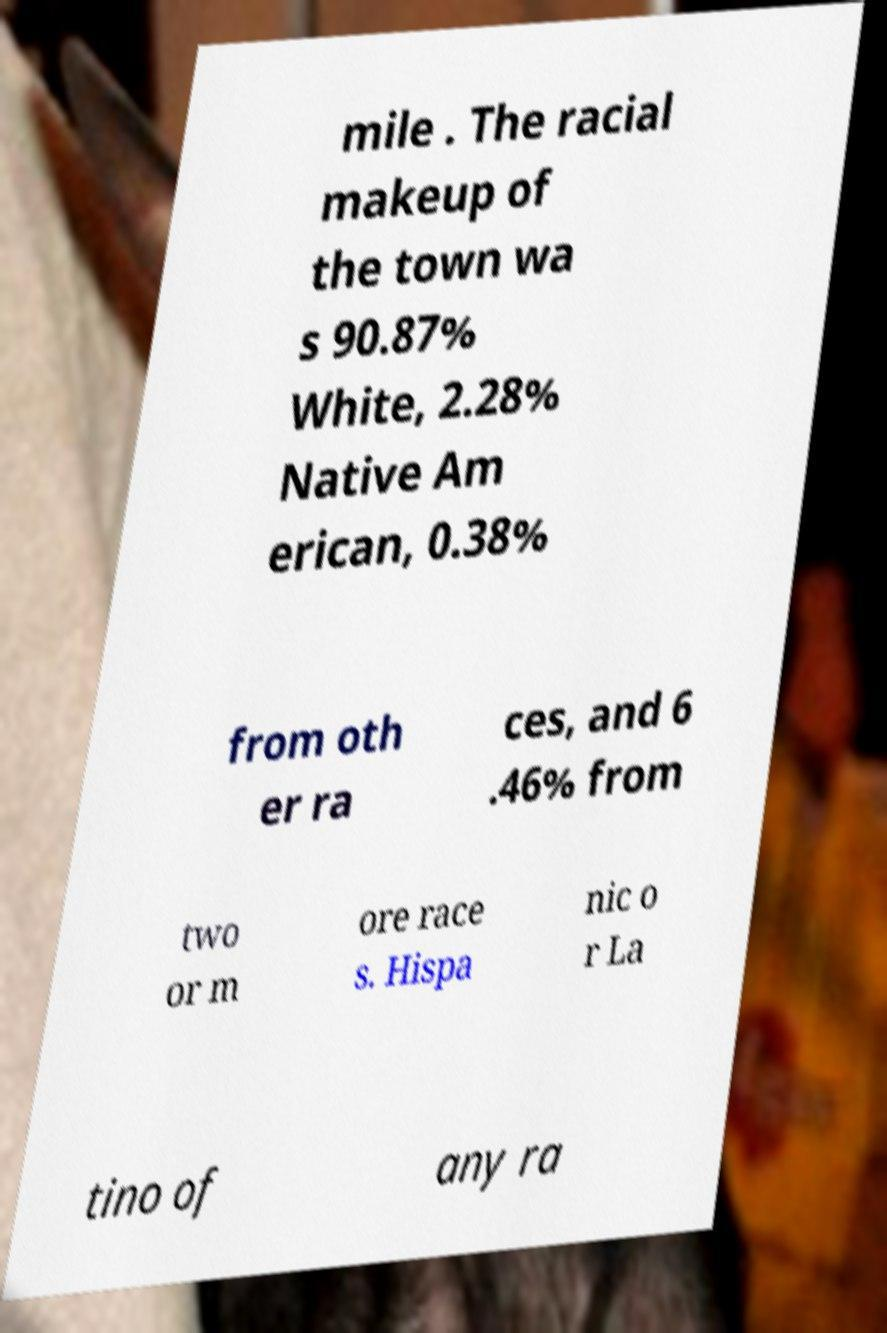For documentation purposes, I need the text within this image transcribed. Could you provide that? mile . The racial makeup of the town wa s 90.87% White, 2.28% Native Am erican, 0.38% from oth er ra ces, and 6 .46% from two or m ore race s. Hispa nic o r La tino of any ra 